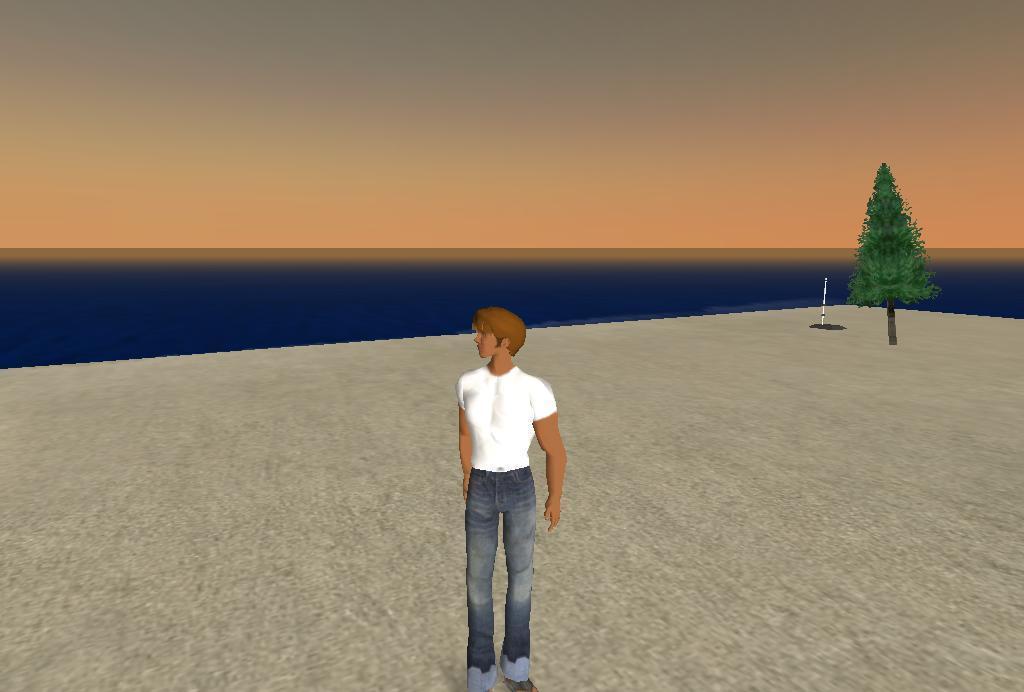Please provide a concise description of this image. This is an animated image in this image there is a person standing on a floor, in the background there is a tree, sea and the sky. 